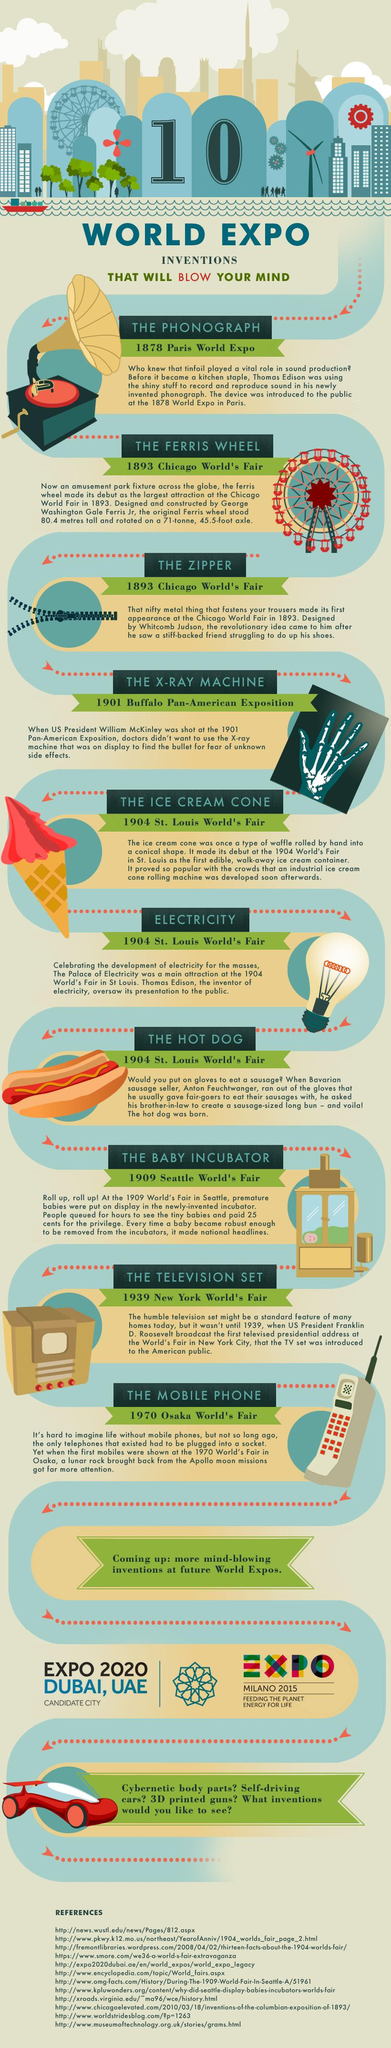Give some essential details in this illustration. The invention that was introduced at the 1970 Osaka World's Fair was the mobile phone. Thomas Edison introduced two inventions at the World Expo that revolutionized music and energy production: the phonograph and electricity. Whitcomb Judson invented the zipper in 1893. The fee charged to view the infants in the incubator was 25 cents. The X-ray machine was introduced at the Buffalo Pan-American exposition. This invention was revolutionary for its time and paved the way for advancements in medical technology. 